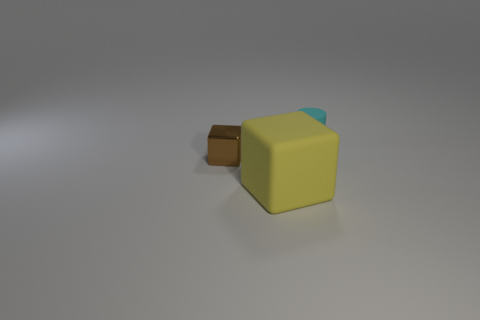What is the texture of the surfaces, and how do they interact with the light? The surfaces appear to have a matte texture, diffusing the light softly without significant reflection or glossiness. This diffuse reflection indicates that the surface is likely non-metallic and has a uniformly rough texture on a microscopic level. 